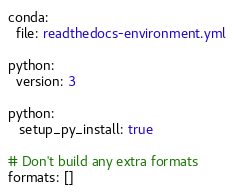Convert code to text. <code><loc_0><loc_0><loc_500><loc_500><_YAML_>conda:
  file: readthedocs-environment.yml

python:
  version: 3

python:
   setup_py_install: true

# Don't build any extra formats
formats: []</code> 